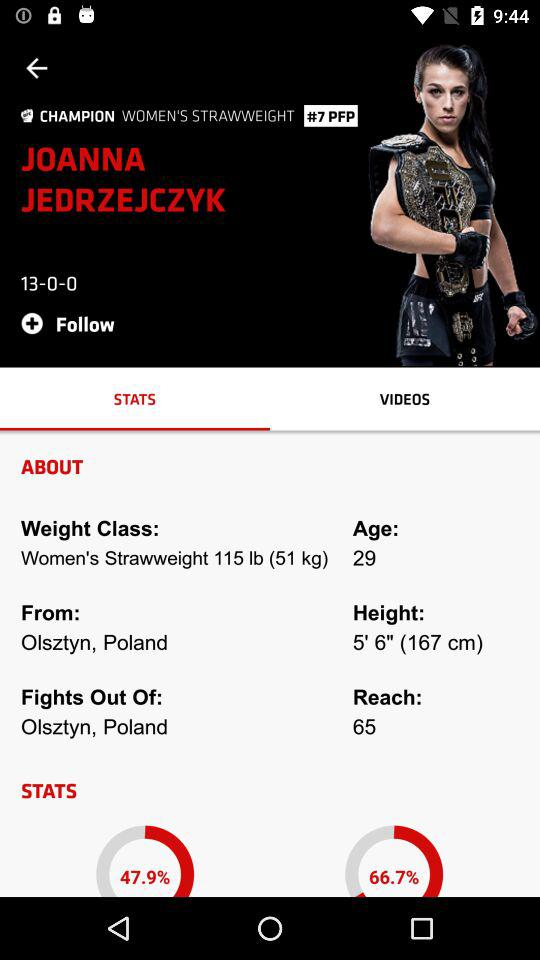How many more wins does Joanna Jedrzejczyk have than losses?
Answer the question using a single word or phrase. 13 